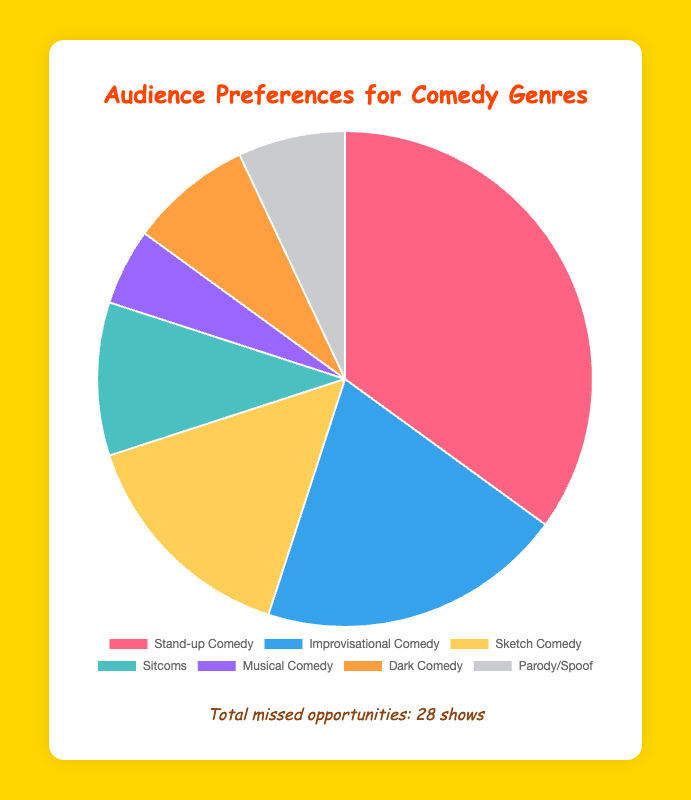What percentage of the audience prefers Stand-up Comedy? The chart provides the proportions of preferences. Stand-up Comedy has a preference value of 35 out of a total sum of 100 (since it's a percentage). Therefore, the percentage is shown directly on the chart.
Answer: 35% How many comedy shows were missed in total? The total missed show attendance is the sum of missed shows across all genres: 5 (Stand-up) + 7 (Improvisational) + 4 (Sketch) + 2 (Sitcoms) + 3 (Musical) + 6 (Dark) + 1 (Parody) = 28.
Answer: 28 Which comedy genre has the highest missed attendance? The chart shows missed attendance values. Improvisational Comedy has the highest missed attendance value of 7.
Answer: Improvisational Comedy What is the combined audience preference for Sitcoms and Musical Comedy? The chart shows individual preferences. Adding Sitcoms (10) and Musical Comedy (5) gives a total of 15.
Answer: 15 What is the difference in missed attendance between Sketch Comedy and Dark Comedy? The chart shows missed attendance values. For Sketch Comedy it is 4, and for Dark Comedy it is 6. The difference is 6 - 4 = 2.
Answer: 2 What color represents the segment for Parody/Spoof? The pie chart uses specific colors for each genre. Parody/Spoof is represented by the grey segment.
Answer: Grey Which genre has a higher audience preference: Dark Comedy or Parody/Spoof? The chart shows preference values. Dark Comedy has 8 and Parody/Spoof has 7. Therefore, Dark Comedy has a higher preference.
Answer: Dark Comedy Is the audience preference for Stand-up Comedy greater than the combined total preference for Sitcoms and Musical Comedy? Stand-up Comedy has a preference of 35, while the combined preference for Sitcoms (10) and Musical Comedy (5) is 15. Since 35 > 15, Stand-up Comedy has a greater preference.
Answer: Yes What percentage of the audience prefers Dark Comedy? The chart displays preference values. Dark Comedy has a preference value of 8%. This information can be directly obtained from the chart.
Answer: 8% How many more shows were missed for Improvisational Comedy compared to Sitcoms? The chart shows missed attendance values. Improvisational Comedy has 7 missed while Sitcoms have 2. The difference is 7 - 2 = 5.
Answer: 5 